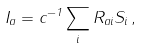Convert formula to latex. <formula><loc_0><loc_0><loc_500><loc_500>I _ { a } = c ^ { - 1 } \sum _ { i } R _ { a i } S _ { i } \, ,</formula> 